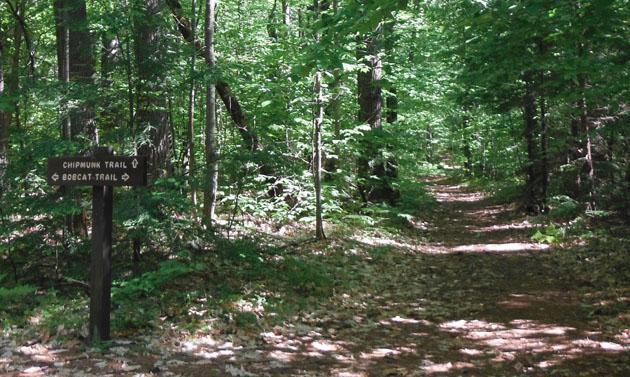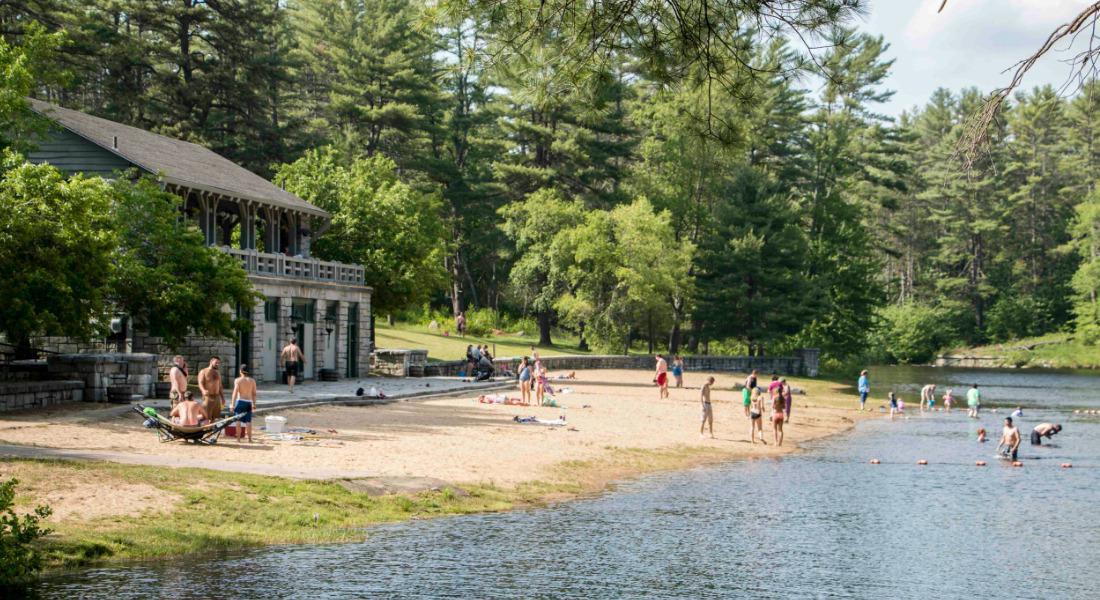The first image is the image on the left, the second image is the image on the right. Given the left and right images, does the statement "An image shows a gray stone building with a straight peaked gray roof in front of a stretch of beach on a lake." hold true? Answer yes or no. Yes. The first image is the image on the left, the second image is the image on the right. Analyze the images presented: Is the assertion "There is a two story event house nestled into the wood looking over a beach." valid? Answer yes or no. Yes. 